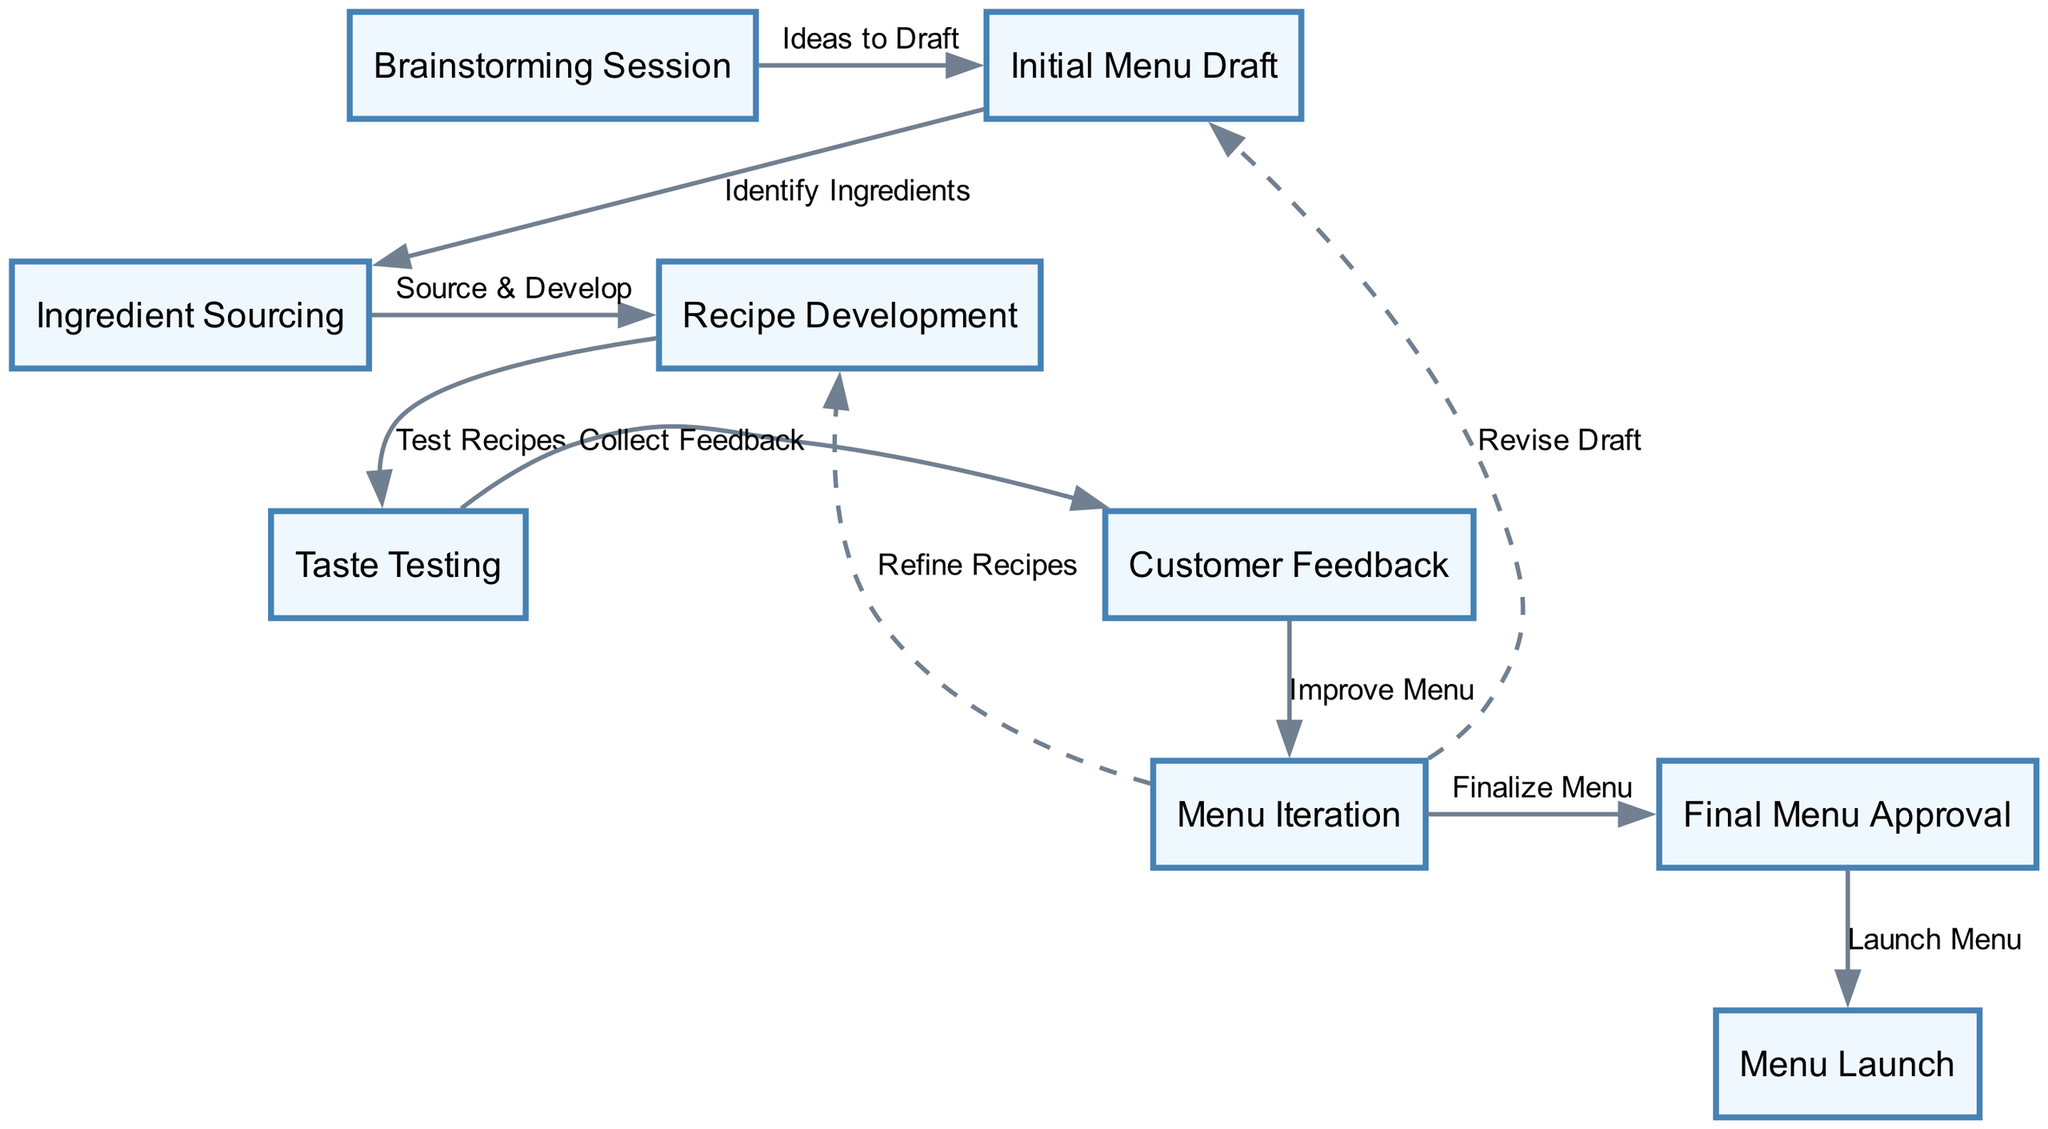What is the first step in the menu development process? The first step in the diagram is clearly labeled as "Brainstorming Session". It is represented as the starting node leading to the flow of menu development.
Answer: Brainstorming Session How many nodes are in the diagram? By counting all the different steps and elements represented in the diagram, we find a total of nine distinct nodes, each corresponding to a specific stage in the menu development process.
Answer: Nine What process follows the taste testing? The next process after "Taste Testing" is "Customer Feedback". This shows the direct progression from gathering taste testing results to analyzing customer input.
Answer: Customer Feedback Which step involves refining recipes? The step that involves refining recipes is "Recipe Development". This is indicated by the dashed line that connects "Menu Iteration" back to "Recipe Development", suggesting that the process of iteration requires revisiting recipes.
Answer: Recipe Development What is the final step before the menu is launched? The final step prior to the launch of the menu is "Menu Launch". This step is the last one in the flow, indicating that once the menu is approved, it is ready to be launched to customers.
Answer: Menu Launch How many feedback loops are present in the diagram? There are two feedback loops present, indicated by the dashed lines originating from "Menu Iteration" back to "Recipe Development" and "Initial Menu Draft", which represent the iterative nature of refining the menu based on testing and feedback.
Answer: Two Which stage follows ingredient sourcing? The stage that comes after "Ingredient Sourcing" is "Recipe Development". The diagram shows how sourcing ingredients leads to the development of actual recipes.
Answer: Recipe Development What is the label of the edge connecting "Taste Testing" to "Customer Feedback"? The edge connecting "Taste Testing" to "Customer Feedback" is labeled "Collect Feedback". This explicitly describes the action taken after taste testing in the process.
Answer: Collect Feedback 